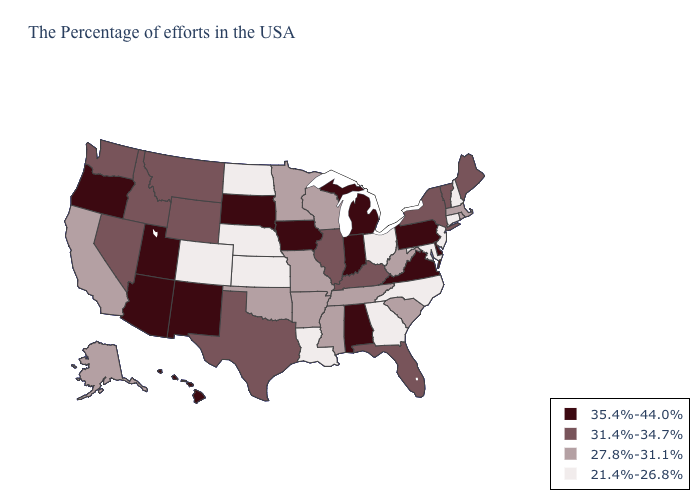Is the legend a continuous bar?
Be succinct. No. What is the highest value in states that border West Virginia?
Quick response, please. 35.4%-44.0%. What is the highest value in the USA?
Keep it brief. 35.4%-44.0%. Does the map have missing data?
Give a very brief answer. No. What is the highest value in the Northeast ?
Be succinct. 35.4%-44.0%. What is the value of New Mexico?
Write a very short answer. 35.4%-44.0%. What is the value of Texas?
Answer briefly. 31.4%-34.7%. What is the highest value in the USA?
Quick response, please. 35.4%-44.0%. What is the value of Alabama?
Concise answer only. 35.4%-44.0%. Name the states that have a value in the range 27.8%-31.1%?
Be succinct. Massachusetts, Rhode Island, South Carolina, West Virginia, Tennessee, Wisconsin, Mississippi, Missouri, Arkansas, Minnesota, Oklahoma, California, Alaska. What is the value of Hawaii?
Write a very short answer. 35.4%-44.0%. Name the states that have a value in the range 27.8%-31.1%?
Short answer required. Massachusetts, Rhode Island, South Carolina, West Virginia, Tennessee, Wisconsin, Mississippi, Missouri, Arkansas, Minnesota, Oklahoma, California, Alaska. Does the first symbol in the legend represent the smallest category?
Quick response, please. No. What is the value of South Carolina?
Keep it brief. 27.8%-31.1%. What is the value of Nebraska?
Keep it brief. 21.4%-26.8%. 